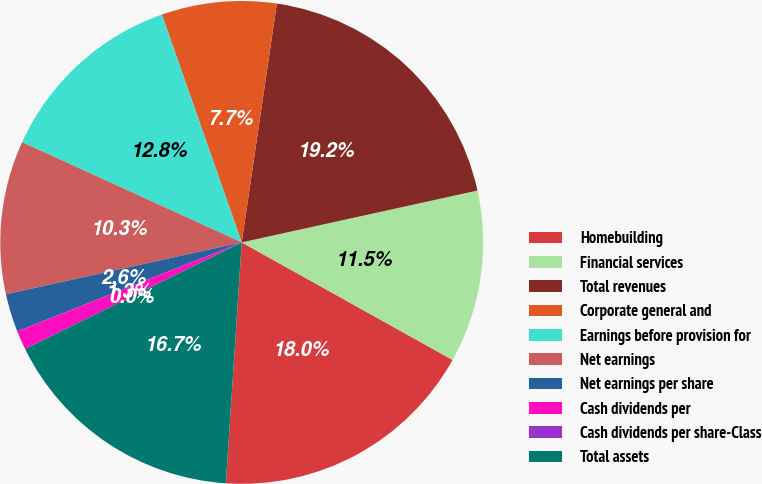Convert chart to OTSL. <chart><loc_0><loc_0><loc_500><loc_500><pie_chart><fcel>Homebuilding<fcel>Financial services<fcel>Total revenues<fcel>Corporate general and<fcel>Earnings before provision for<fcel>Net earnings<fcel>Net earnings per share<fcel>Cash dividends per<fcel>Cash dividends per share-Class<fcel>Total assets<nl><fcel>17.95%<fcel>11.54%<fcel>19.23%<fcel>7.69%<fcel>12.82%<fcel>10.26%<fcel>2.56%<fcel>1.28%<fcel>0.0%<fcel>16.67%<nl></chart> 